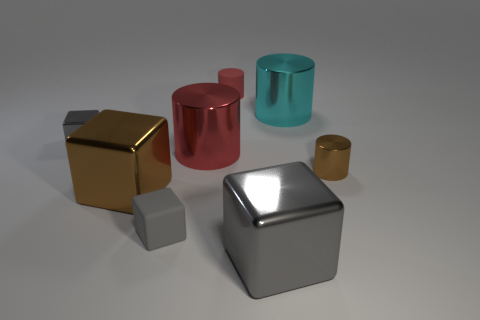How many gray cubes must be subtracted to get 1 gray cubes? 2 Subtract all yellow cylinders. How many gray cubes are left? 3 Subtract 1 cylinders. How many cylinders are left? 3 Subtract all purple cylinders. Subtract all yellow cubes. How many cylinders are left? 4 Add 1 tiny red spheres. How many objects exist? 9 Add 1 purple shiny cylinders. How many purple shiny cylinders exist? 1 Subtract 0 cyan cubes. How many objects are left? 8 Subtract all gray blocks. Subtract all brown matte things. How many objects are left? 5 Add 6 tiny metal cubes. How many tiny metal cubes are left? 7 